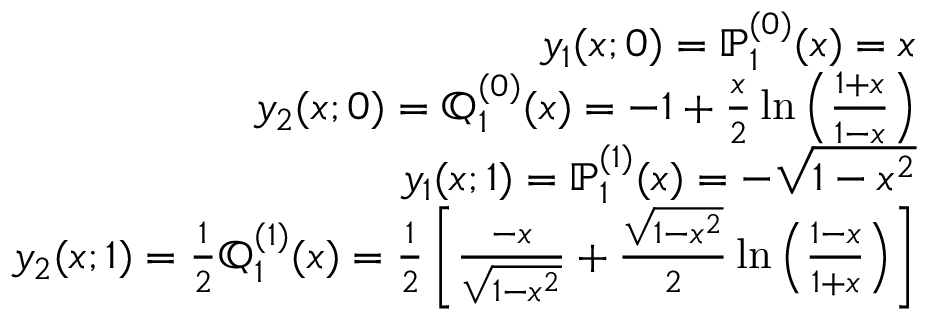<formula> <loc_0><loc_0><loc_500><loc_500>\begin{array} { r l r } & { y _ { 1 } ( x ; 0 ) = \mathbb { P } _ { 1 } ^ { ( 0 ) } ( x ) = x } \\ & { y _ { 2 } ( x ; 0 ) = \mathbb { Q } _ { 1 } ^ { ( 0 ) } ( x ) = - 1 + \frac { x } { 2 } \ln \left ( \frac { 1 + x } { 1 - x } \right ) } \\ & { y _ { 1 } ( x ; 1 ) = \mathbb { P } _ { 1 } ^ { ( 1 ) } ( x ) = - \sqrt { 1 - x ^ { 2 } } } \\ & { y _ { 2 } ( x ; 1 ) = \frac { 1 } { 2 } \mathbb { Q } _ { 1 } ^ { ( 1 ) } ( x ) = \frac { 1 } { 2 } \left [ \frac { - x } { \sqrt { 1 - x ^ { 2 } } } + \frac { \sqrt { 1 - x ^ { 2 } } } { 2 } \ln \left ( \frac { 1 - x } { 1 + x } \right ) \right ] } \end{array}</formula> 